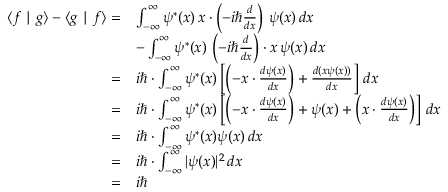<formula> <loc_0><loc_0><loc_500><loc_500>{ \begin{array} { r l } { \langle f | g \rangle - \langle g | f \rangle = } & { \int _ { - \infty } ^ { \infty } \psi ^ { * } ( x ) \, x \cdot \left ( - i \hbar { \frac { d } { d x } } \right ) \, \psi ( x ) \, d x } \\ & { - \int _ { - \infty } ^ { \infty } \psi ^ { * } ( x ) \, \left ( - i \hbar { \frac { d } { d x } } \right ) \cdot x \, \psi ( x ) \, d x } \\ { = } & { i \hbar { \cdot } \int _ { - \infty } ^ { \infty } \psi ^ { * } ( x ) \left [ \left ( - x \cdot { \frac { d \psi ( x ) } { d x } } \right ) + { \frac { d ( x \psi ( x ) ) } { d x } } \right ] \, d x } \\ { = } & { i \hbar { \cdot } \int _ { - \infty } ^ { \infty } \psi ^ { * } ( x ) \left [ \left ( - x \cdot { \frac { d \psi ( x ) } { d x } } \right ) + \psi ( x ) + \left ( x \cdot { \frac { d \psi ( x ) } { d x } } \right ) \right ] \, d x } \\ { = } & { i \hbar { \cdot } \int _ { - \infty } ^ { \infty } \psi ^ { * } ( x ) \psi ( x ) \, d x } \\ { = } & { i \hbar { \cdot } \int _ { - \infty } ^ { \infty } | \psi ( x ) | ^ { 2 } \, d x } \\ { = } & { i } \end{array} }</formula> 